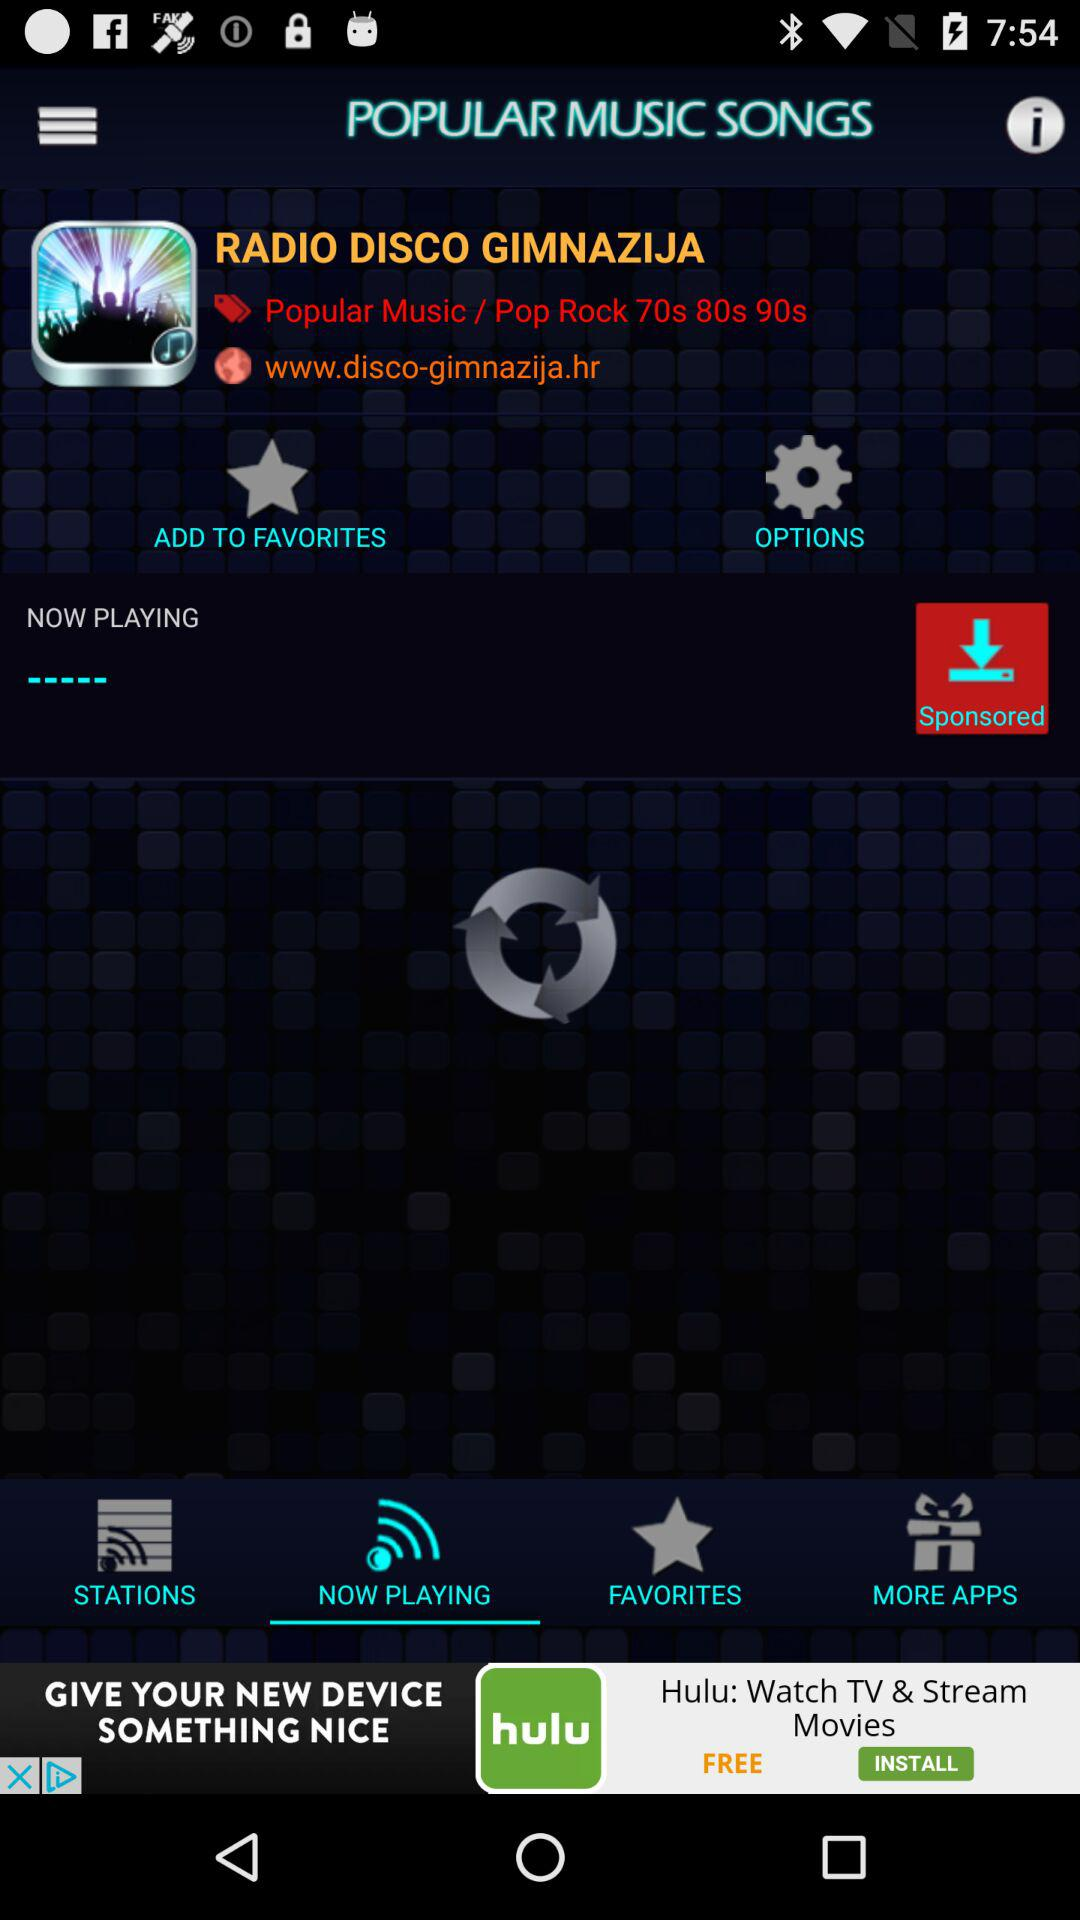Which is the selected tab? The selected tab is "NOW PLAYING". 